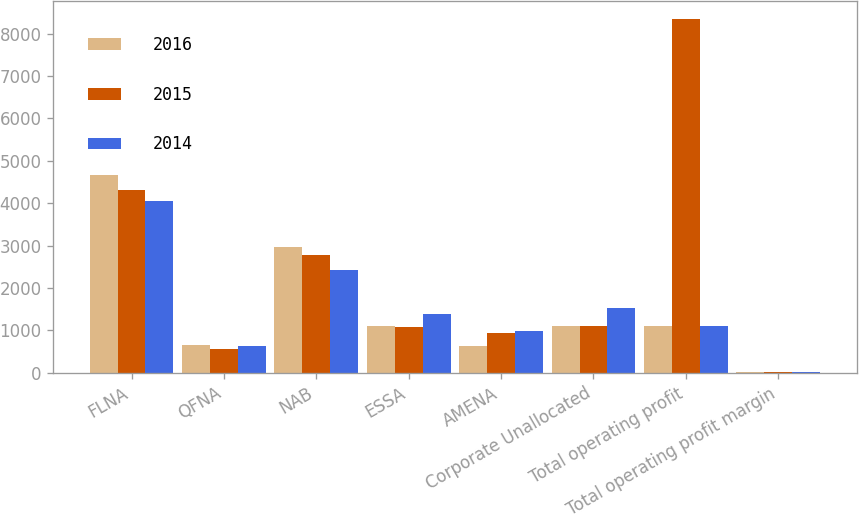<chart> <loc_0><loc_0><loc_500><loc_500><stacked_bar_chart><ecel><fcel>FLNA<fcel>QFNA<fcel>NAB<fcel>ESSA<fcel>AMENA<fcel>Corporate Unallocated<fcel>Total operating profit<fcel>Total operating profit margin<nl><fcel>2016<fcel>4659<fcel>653<fcel>2959<fcel>1108<fcel>619<fcel>1100<fcel>1104<fcel>15.6<nl><fcel>2015<fcel>4304<fcel>560<fcel>2785<fcel>1081<fcel>941<fcel>1112<fcel>8353<fcel>13.2<nl><fcel>2014<fcel>4054<fcel>621<fcel>2421<fcel>1389<fcel>985<fcel>1525<fcel>1104<fcel>14.4<nl></chart> 